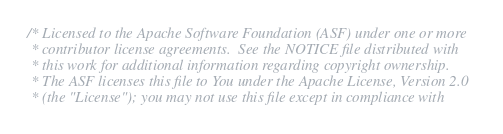<code> <loc_0><loc_0><loc_500><loc_500><_C_>/* Licensed to the Apache Software Foundation (ASF) under one or more
 * contributor license agreements.  See the NOTICE file distributed with
 * this work for additional information regarding copyright ownership.
 * The ASF licenses this file to You under the Apache License, Version 2.0
 * (the "License"); you may not use this file except in compliance with</code> 